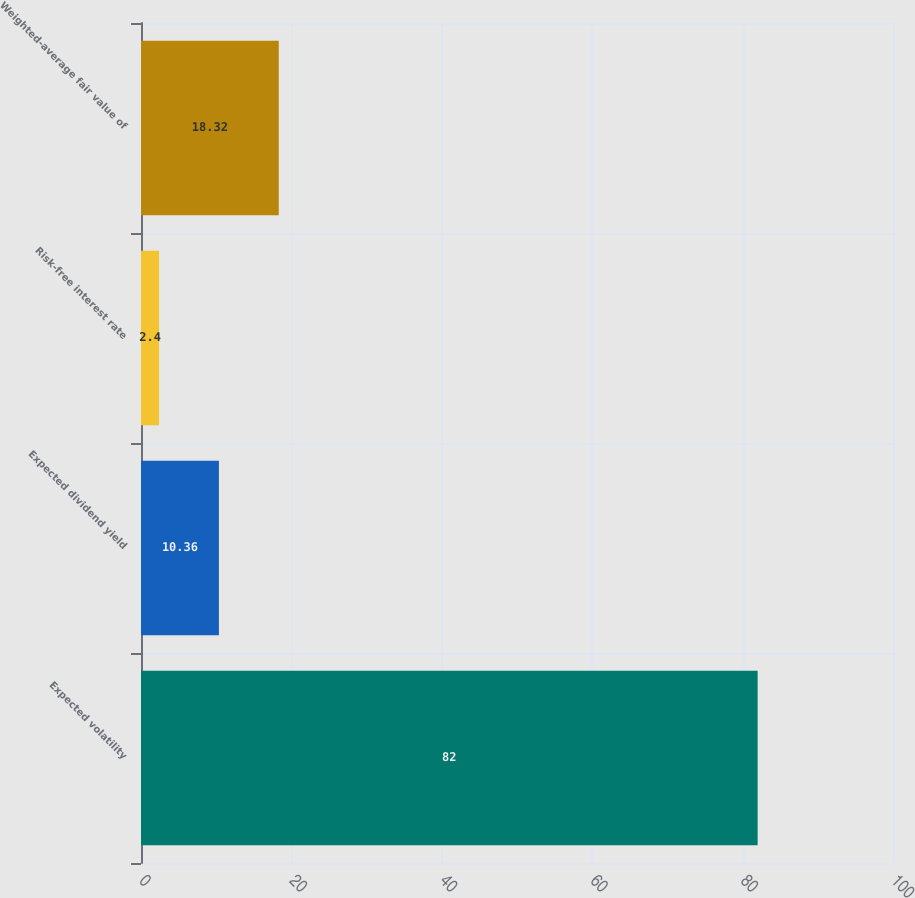<chart> <loc_0><loc_0><loc_500><loc_500><bar_chart><fcel>Expected volatility<fcel>Expected dividend yield<fcel>Risk-free interest rate<fcel>Weighted-average fair value of<nl><fcel>82<fcel>10.36<fcel>2.4<fcel>18.32<nl></chart> 